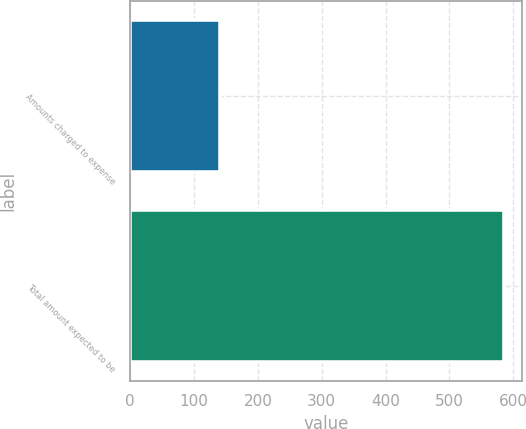<chart> <loc_0><loc_0><loc_500><loc_500><bar_chart><fcel>Amounts charged to expense<fcel>Total amount expected to be<nl><fcel>140<fcel>585<nl></chart> 